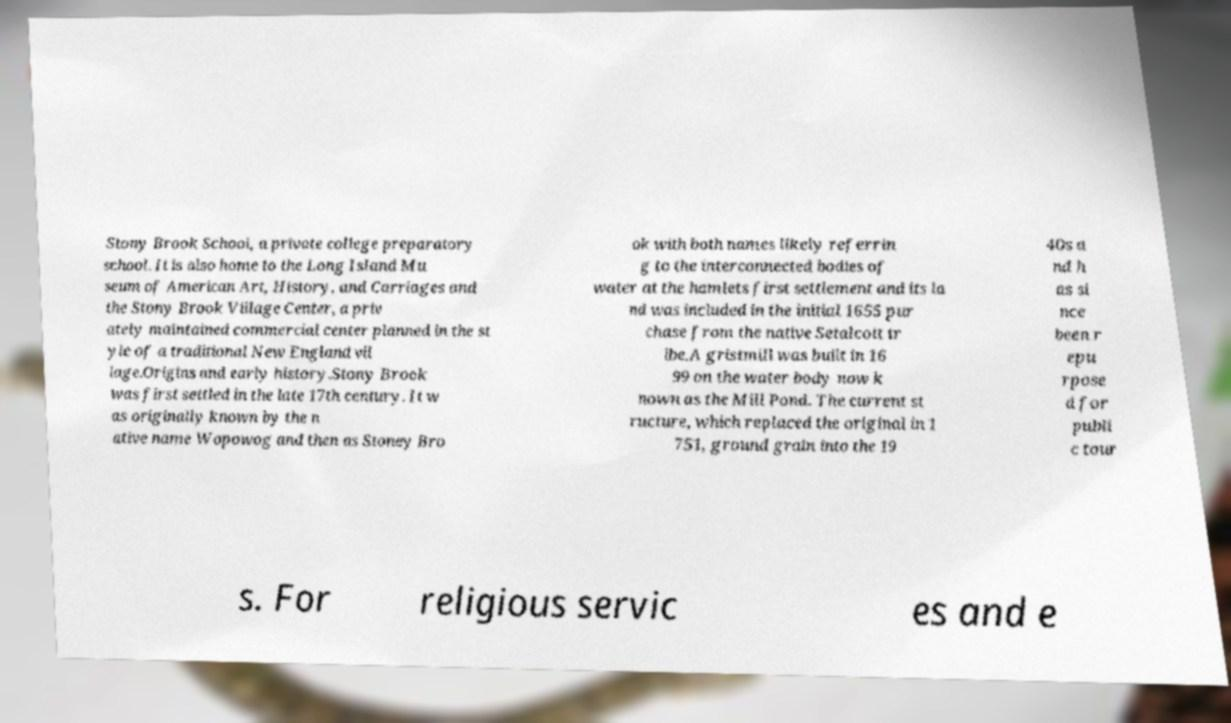Could you extract and type out the text from this image? Stony Brook School, a private college preparatory school. It is also home to the Long Island Mu seum of American Art, History, and Carriages and the Stony Brook Village Center, a priv ately maintained commercial center planned in the st yle of a traditional New England vil lage.Origins and early history.Stony Brook was first settled in the late 17th century. It w as originally known by the n ative name Wopowog and then as Stoney Bro ok with both names likely referrin g to the interconnected bodies of water at the hamlets first settlement and its la nd was included in the initial 1655 pur chase from the native Setalcott tr ibe.A gristmill was built in 16 99 on the water body now k nown as the Mill Pond. The current st ructure, which replaced the original in 1 751, ground grain into the 19 40s a nd h as si nce been r epu rpose d for publi c tour s. For religious servic es and e 